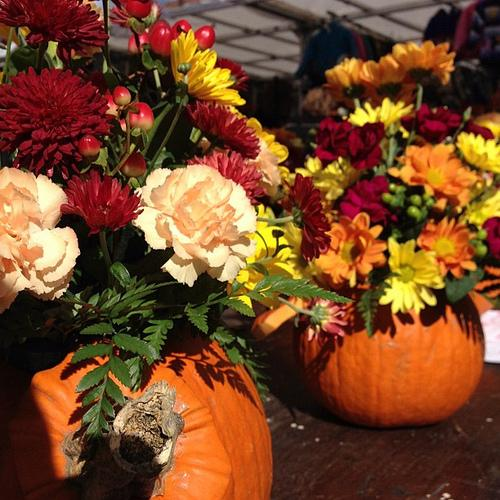In simple words, describe the setting in which the pumpkins are placed. The pumpkins are on a wooden table with a checkered paneled ceiling above. Provide a general description of the image and its sentiment. An autumn-inspired flower arrangement is made by placing flowers inside hollowed-out pumpkins on a wooden table, conveying a cozy and warm sentiment. Mention the primary object and its purpose in the picture. Two pumpkins are being used as flower pots in an autumn-inspired floral arrangement. Comment on the appearance and condition of the pumpkin stem. The pumpkin stem is light brown, and the top of the pumpkin appears withered. How many white flowers are mentioned in the image's captions?  There are two white flowers in the image. What are some additional objects in the image aside from flowers and pumpkins? Orange ribbon, leaves, berries, grooves in the pumpkin, and white spots on the table top. List types of flowers mentioned in the image's captions. Yellow flower, orange flower, white flower, red flower, pink carnation, light yellow daisy, dark red dahlia. What specific type of flower is found in the flower arrangement? A pink carnation and white carnation flowers are in the flower arrangement. Can you describe the state of some flowers in the image?  Some flowers are far from blooming and have not bloomed yet. Identify the colors of flowers in the bouquet. Yellow, orange, white, red, pink, and fuchsia are colors of the flowers in the bouquet. Are there any green flowers in the autumn-inspired floral arrangement? There are no green flowers mentioned in any of the given captions. There are leaves and various other colors of flowers, but no green flowers. Can you see a cat sitting next to the pumpkins on the table? There is no mention of a cat or any other animal in the given captions. Can you find a pineapple on the wood surface next to the pumpkins? There is no mention of a pineapple or any other fruit besides the pumpkins in the given captions. Is there a Christmas ornament hanging from the checkered paneled ceiling? There is no mention of a Christmas ornament or any other holiday decoration in the given captions. Is there a purple ribbon tied around the pumpkin holding flowers? There is no mention of any purple ribbon in the given captions. There is an orange ribbon mentioned but not a purple one. Is the pumpkin on the left filled with blue flowers? There are no blue flowers mentioned in any of the given captions. 